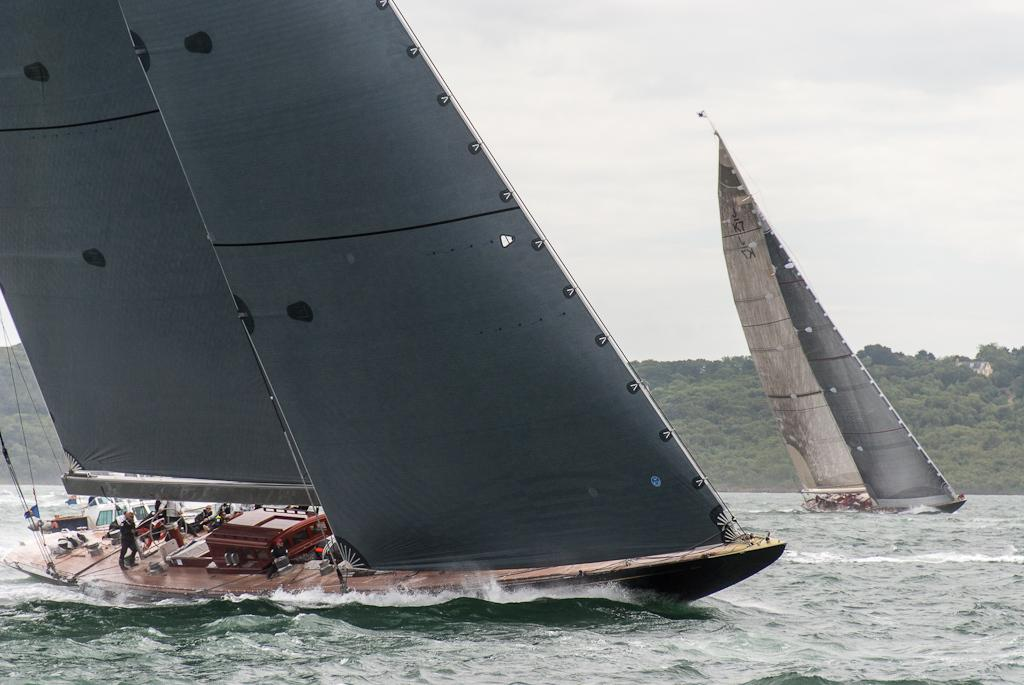What are the people in the image doing? The people in the image are sailing in a boat. What can be seen on the boat? There are objects on the boat. What is the surrounding environment like in the image? There is water visible in the image, as well as trees and the sky. What is the condition of the sky in the image? The sky is visible in the image, and clouds are present. What type of sponge can be seen being used by the carpenter on the swing in the image? There is no sponge, carpenter, or swing present in the image. 